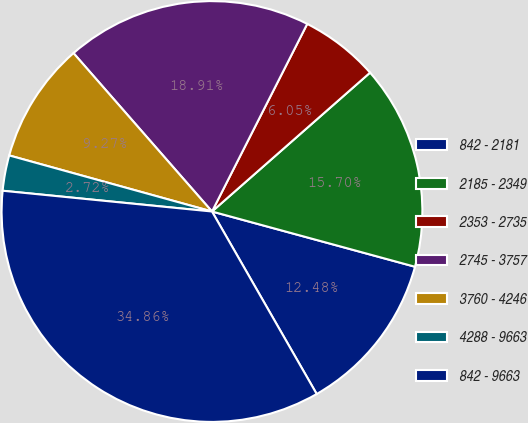Convert chart. <chart><loc_0><loc_0><loc_500><loc_500><pie_chart><fcel>842 - 2181<fcel>2185 - 2349<fcel>2353 - 2735<fcel>2745 - 3757<fcel>3760 - 4246<fcel>4288 - 9663<fcel>842 - 9663<nl><fcel>12.48%<fcel>15.7%<fcel>6.05%<fcel>18.91%<fcel>9.27%<fcel>2.72%<fcel>34.86%<nl></chart> 